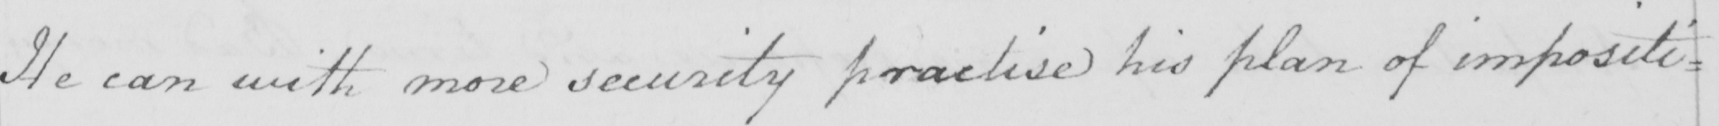Please transcribe the handwritten text in this image. He can with more security practise his plan of impositi= 